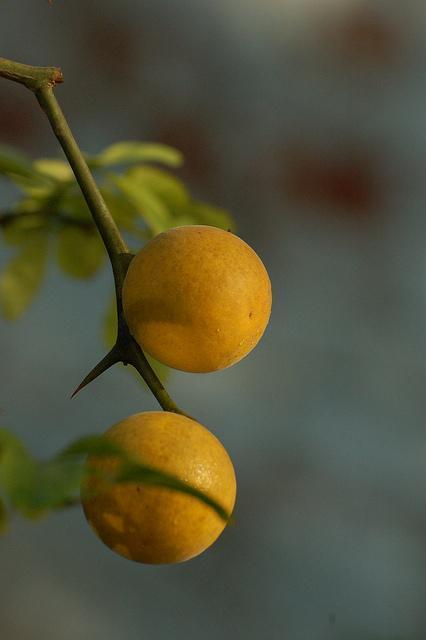How many pieces of fruit are in this photograph?
Give a very brief answer. 2. How many oranges are in the photo?
Give a very brief answer. 2. How many people are wearing white shirt?
Give a very brief answer. 0. 